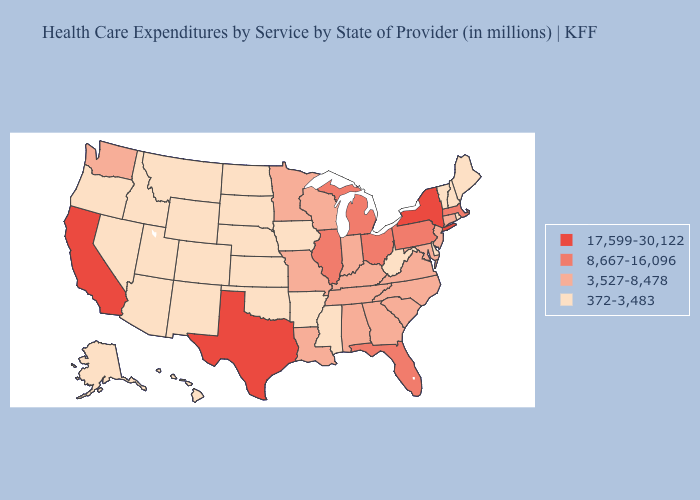Does Alaska have the same value as Massachusetts?
Short answer required. No. What is the highest value in the MidWest ?
Answer briefly. 8,667-16,096. Name the states that have a value in the range 17,599-30,122?
Answer briefly. California, New York, Texas. Does Colorado have a lower value than Idaho?
Give a very brief answer. No. Does Florida have the same value as Illinois?
Answer briefly. Yes. What is the highest value in the USA?
Write a very short answer. 17,599-30,122. Which states have the highest value in the USA?
Short answer required. California, New York, Texas. How many symbols are there in the legend?
Concise answer only. 4. What is the value of Ohio?
Be succinct. 8,667-16,096. Name the states that have a value in the range 3,527-8,478?
Write a very short answer. Alabama, Connecticut, Georgia, Indiana, Kentucky, Louisiana, Maryland, Minnesota, Missouri, New Jersey, North Carolina, South Carolina, Tennessee, Virginia, Washington, Wisconsin. Which states have the highest value in the USA?
Quick response, please. California, New York, Texas. What is the value of Oklahoma?
Answer briefly. 372-3,483. Name the states that have a value in the range 8,667-16,096?
Concise answer only. Florida, Illinois, Massachusetts, Michigan, Ohio, Pennsylvania. What is the value of New Hampshire?
Give a very brief answer. 372-3,483. What is the value of Louisiana?
Be succinct. 3,527-8,478. 